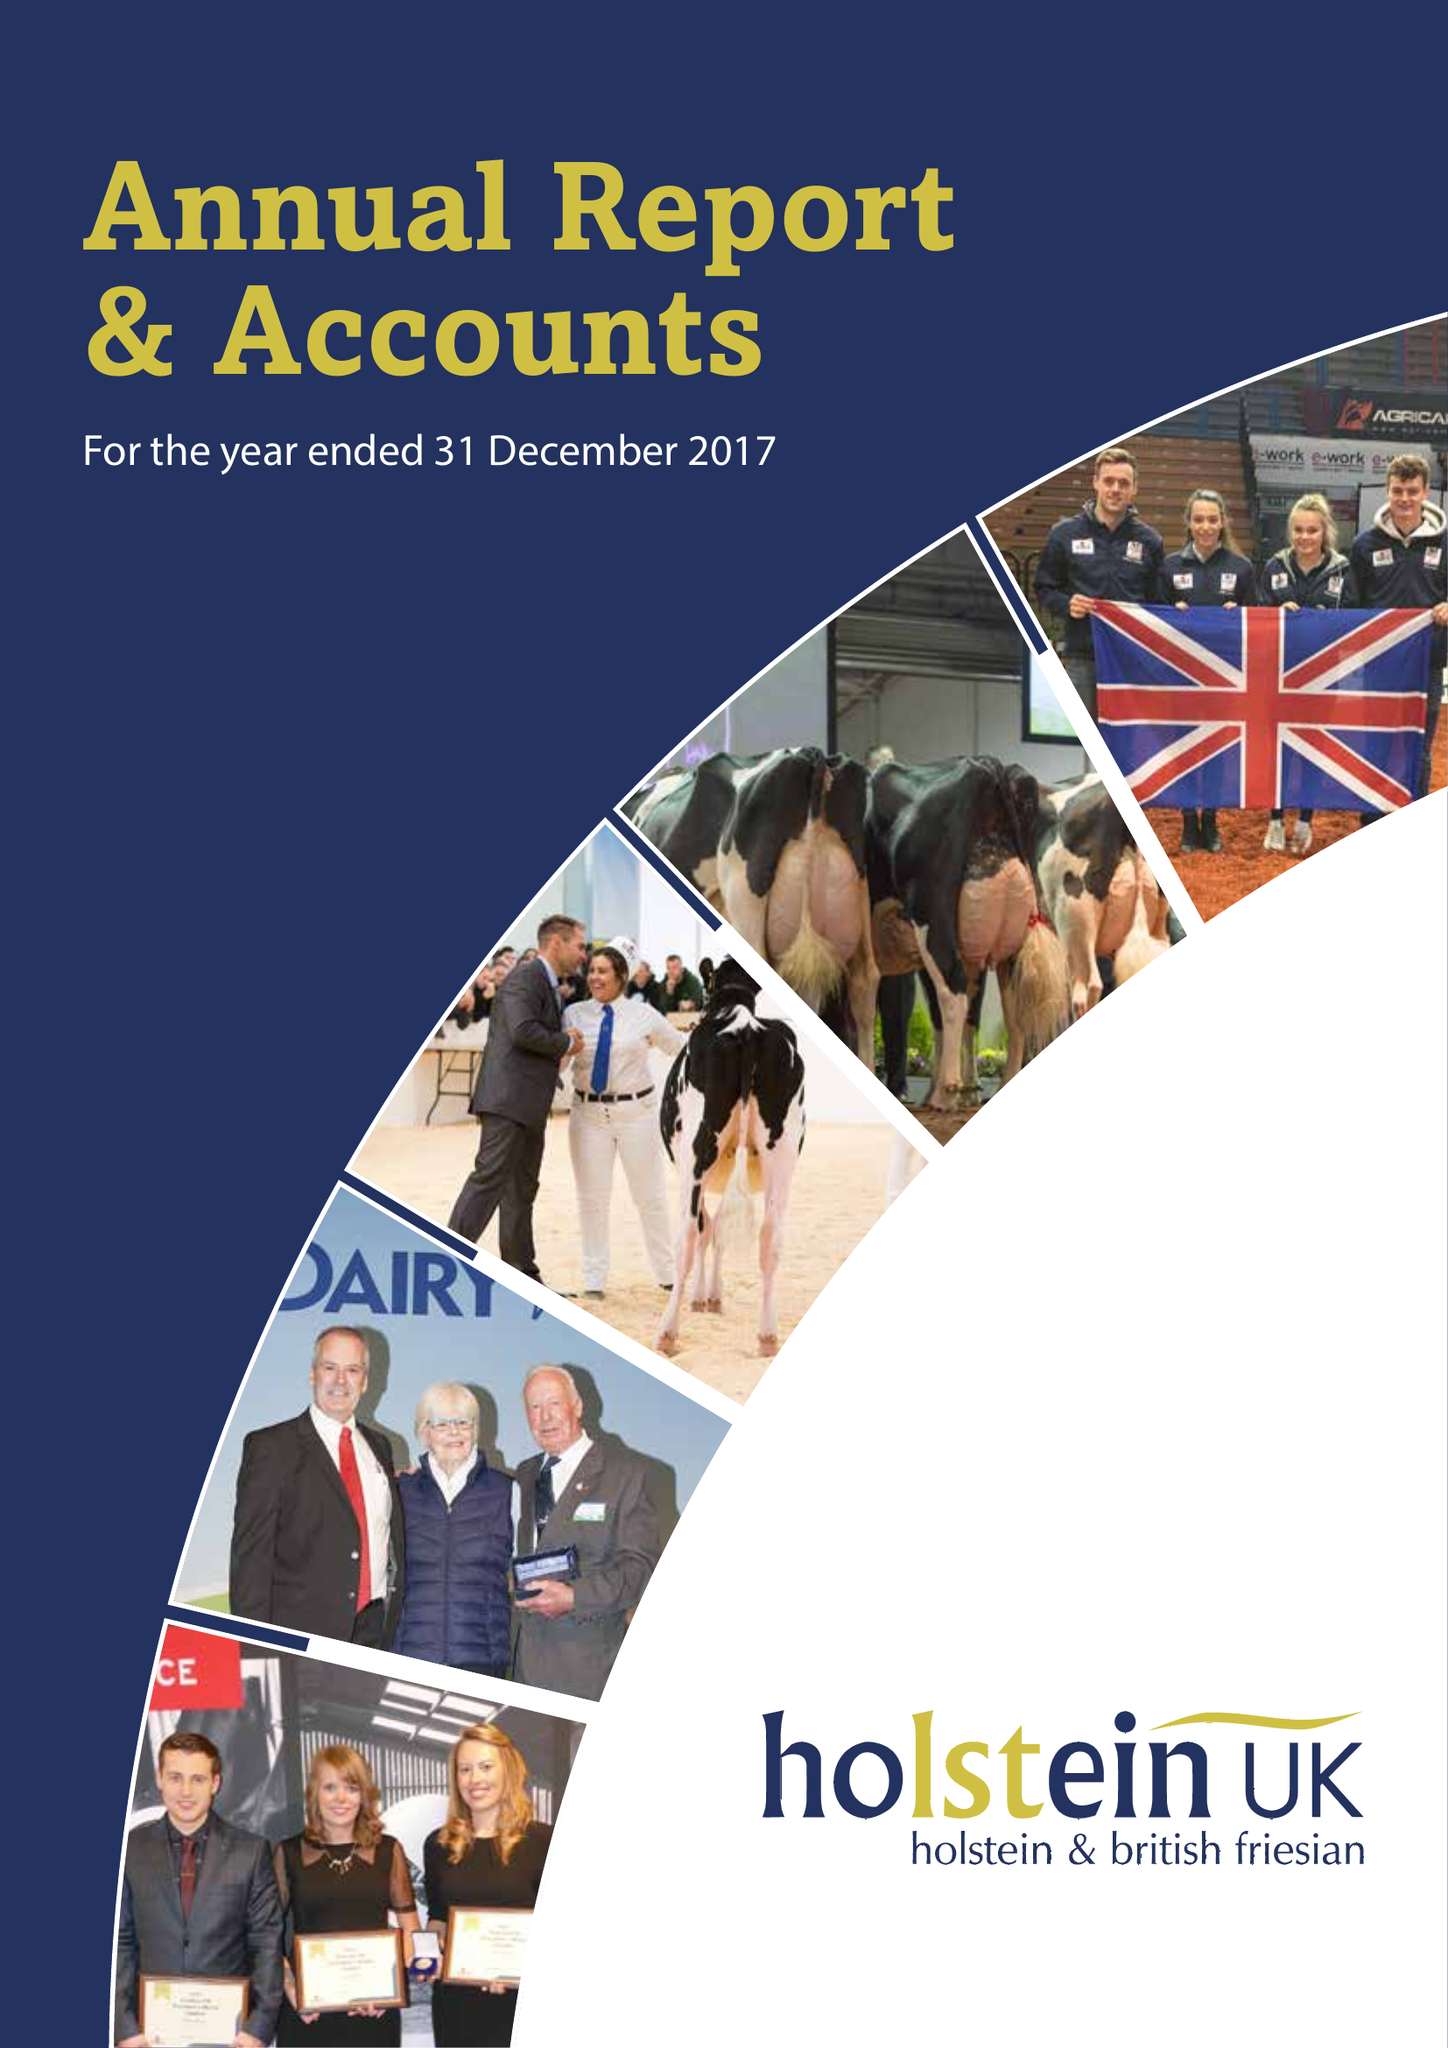What is the value for the address__post_town?
Answer the question using a single word or phrase. TELFORD 